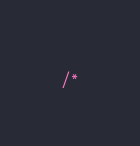Convert code to text. <code><loc_0><loc_0><loc_500><loc_500><_CSS_>/*</code> 